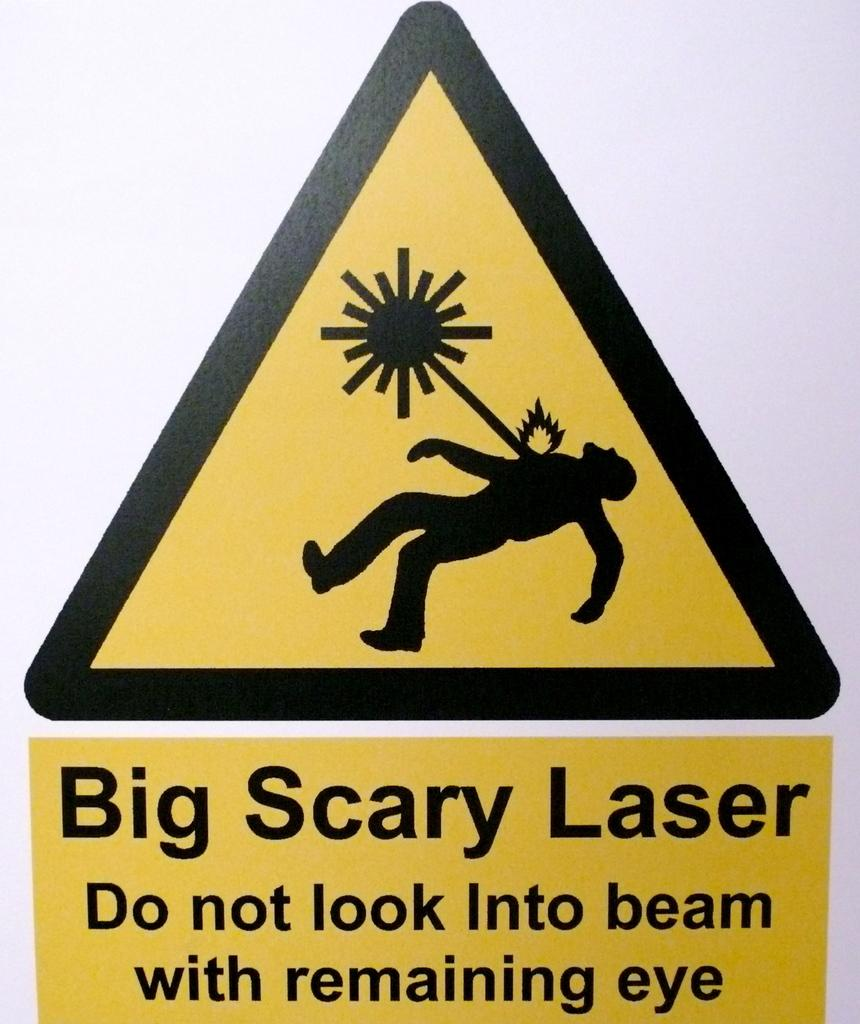<image>
Relay a brief, clear account of the picture shown. A humorous sign warning against looking into a laser beam. 